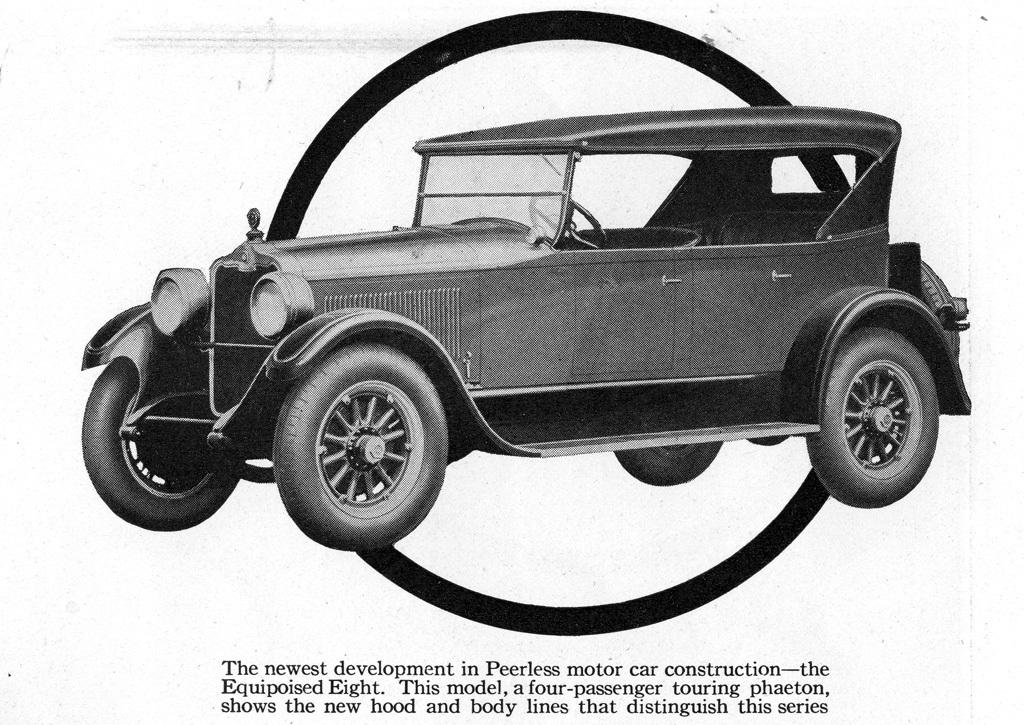What is the color scheme of the image? The image is black and white. What can be seen in the image? There is a car in the image. Is there any text in the image? Yes, there is text below the car in the image. What type of veil is draped over the car in the image? There is no veil present in the image; it is a black and white image of a car with text below it. 